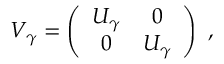<formula> <loc_0><loc_0><loc_500><loc_500>V _ { \gamma } = \left ( \begin{array} { c c } { { U _ { \gamma } } } & { 0 } \\ { 0 } & { { U _ { \gamma } } } \end{array} \right ) ,</formula> 